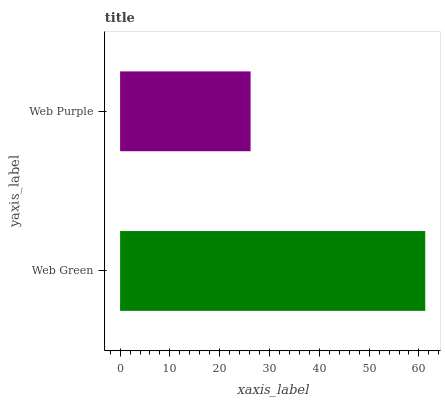Is Web Purple the minimum?
Answer yes or no. Yes. Is Web Green the maximum?
Answer yes or no. Yes. Is Web Purple the maximum?
Answer yes or no. No. Is Web Green greater than Web Purple?
Answer yes or no. Yes. Is Web Purple less than Web Green?
Answer yes or no. Yes. Is Web Purple greater than Web Green?
Answer yes or no. No. Is Web Green less than Web Purple?
Answer yes or no. No. Is Web Green the high median?
Answer yes or no. Yes. Is Web Purple the low median?
Answer yes or no. Yes. Is Web Purple the high median?
Answer yes or no. No. Is Web Green the low median?
Answer yes or no. No. 